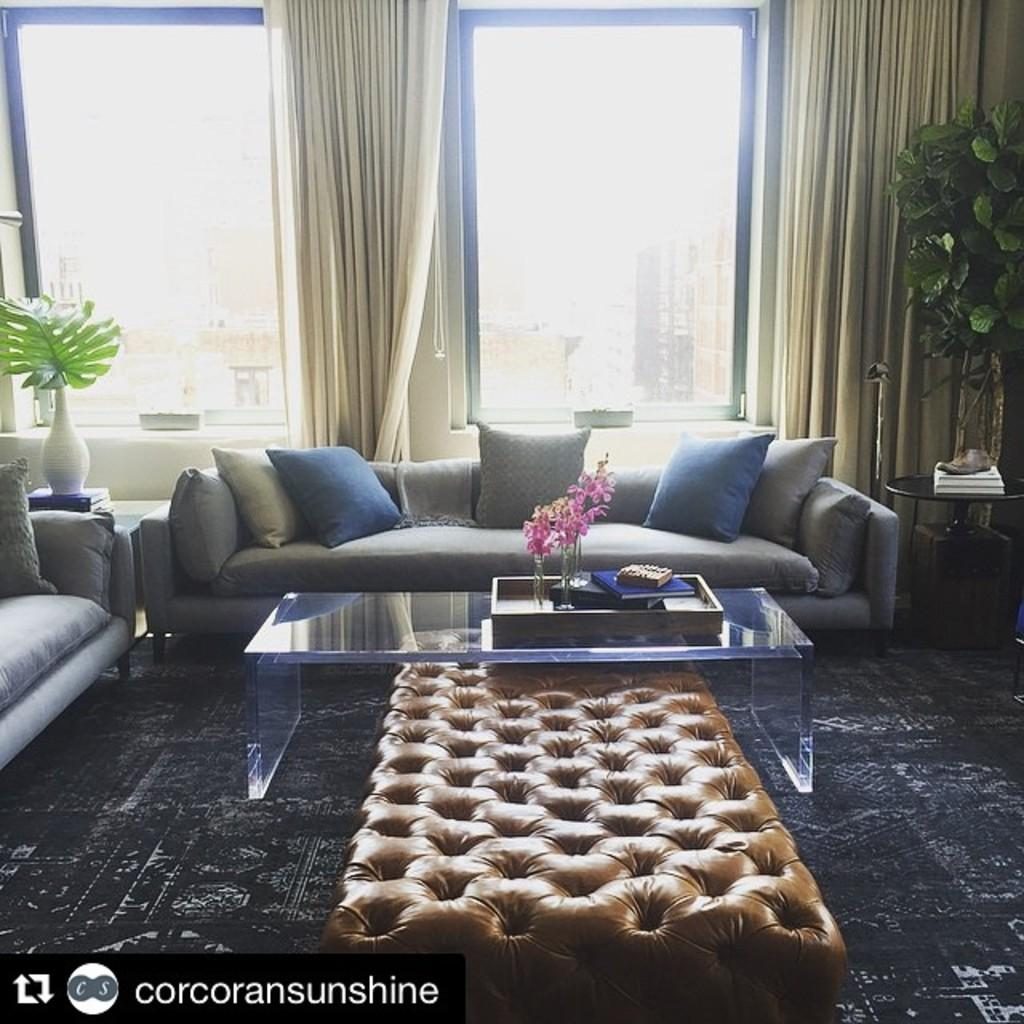What type of furniture is present in the room? There is a sofa and a table in the room. What kind of decorative element can be found in the room? There is a house plant in the room. What feature allows natural light to enter the room? There is a window in the room. Is there any window treatment present in the room? Yes, there is a curtain associated with the window. What type of silk material is draped over the sofa in the image? There is no silk material draped over the sofa in the image; it is a regular sofa without any additional fabric. 